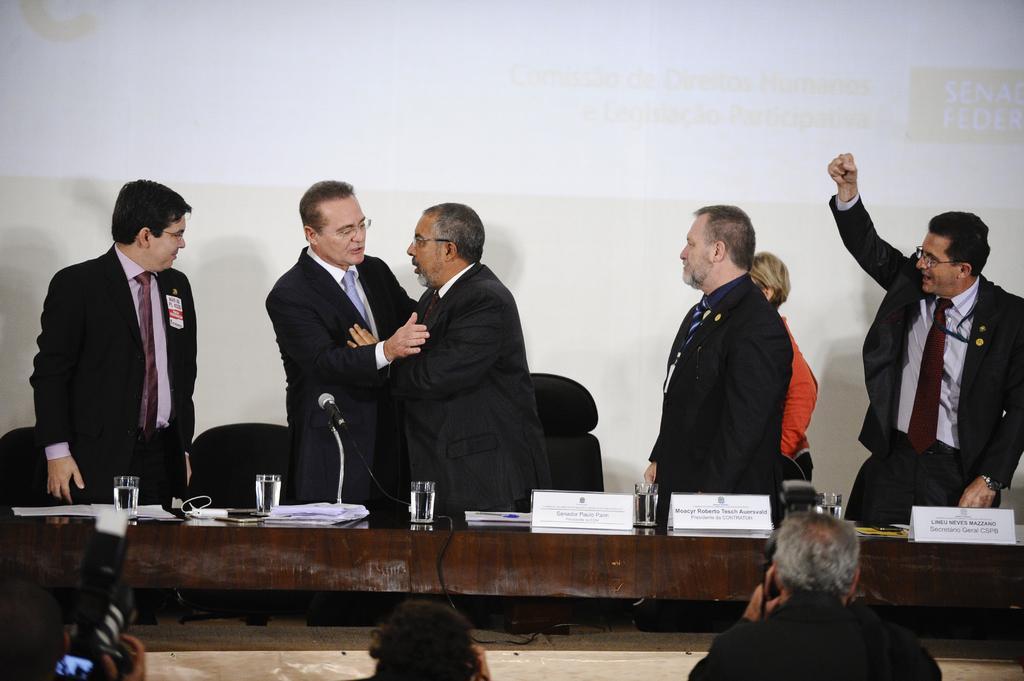Please provide a concise description of this image. In this picture I can see two persons holding the cameras, in the middle there are water glasses and boards on a table, I can see few men standing. In the background it looks like a projector screen. 